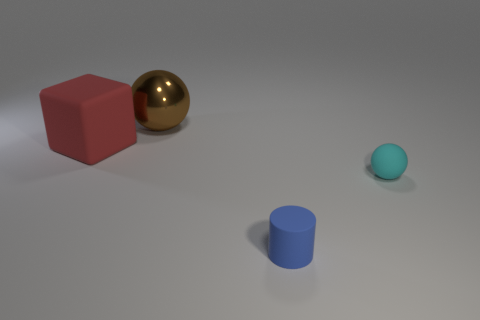Is there any other thing that has the same material as the brown thing?
Offer a terse response. No. There is a ball that is behind the red matte block; does it have the same size as the blue matte thing?
Offer a very short reply. No. What color is the matte thing that is the same shape as the brown metallic thing?
Make the answer very short. Cyan. Are there any other things that are the same shape as the large brown thing?
Offer a terse response. Yes. There is a matte thing that is behind the cyan rubber sphere; what shape is it?
Make the answer very short. Cube. How many big red objects are the same shape as the brown thing?
Your answer should be very brief. 0. Is the color of the ball that is on the right side of the big brown metallic object the same as the small thing in front of the cyan rubber thing?
Your response must be concise. No. What number of objects are either blue matte things or big gray balls?
Offer a terse response. 1. How many large red blocks are the same material as the big red object?
Offer a very short reply. 0. Are there fewer yellow matte cylinders than large brown metallic balls?
Keep it short and to the point. Yes. 